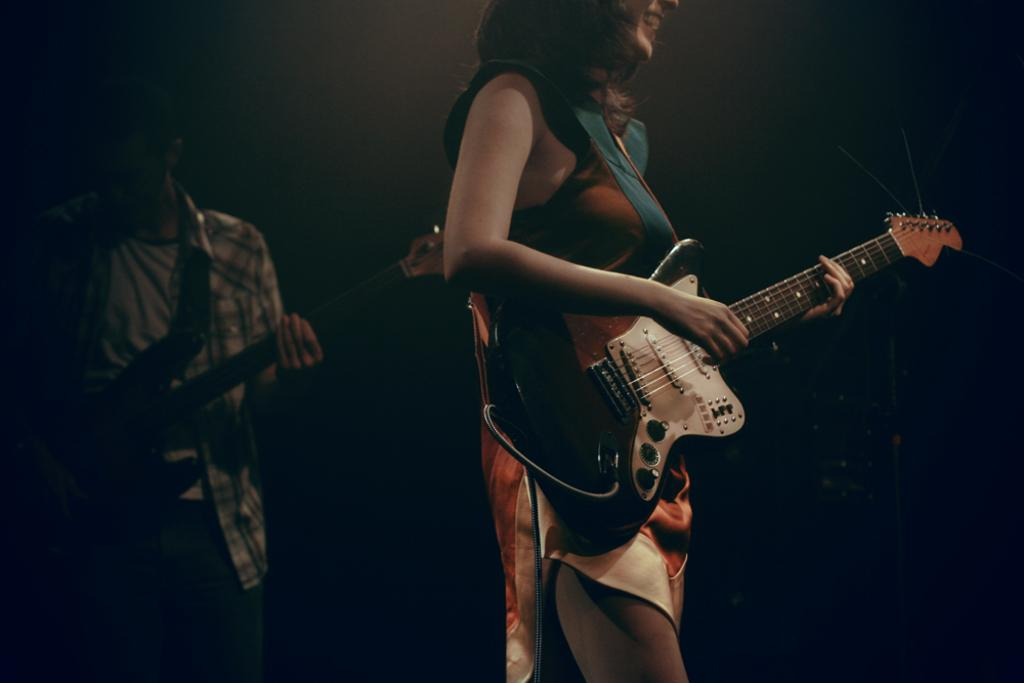Who is the main subject in the image? There is a woman standing at the center of the image. What is the woman holding in her hand? The woman is holding a guitar in her hand. What is the woman's facial expression in the image? The woman is smiling. Who else is present in the image? There is a man standing on the left side of the image. What is the man holding in his hand? The man is holding a guitar in his hand. What type of destruction can be seen in the image? There is no destruction present in the image; it features a woman and a man holding guitars and smiling. 